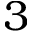<formula> <loc_0><loc_0><loc_500><loc_500>3</formula> 